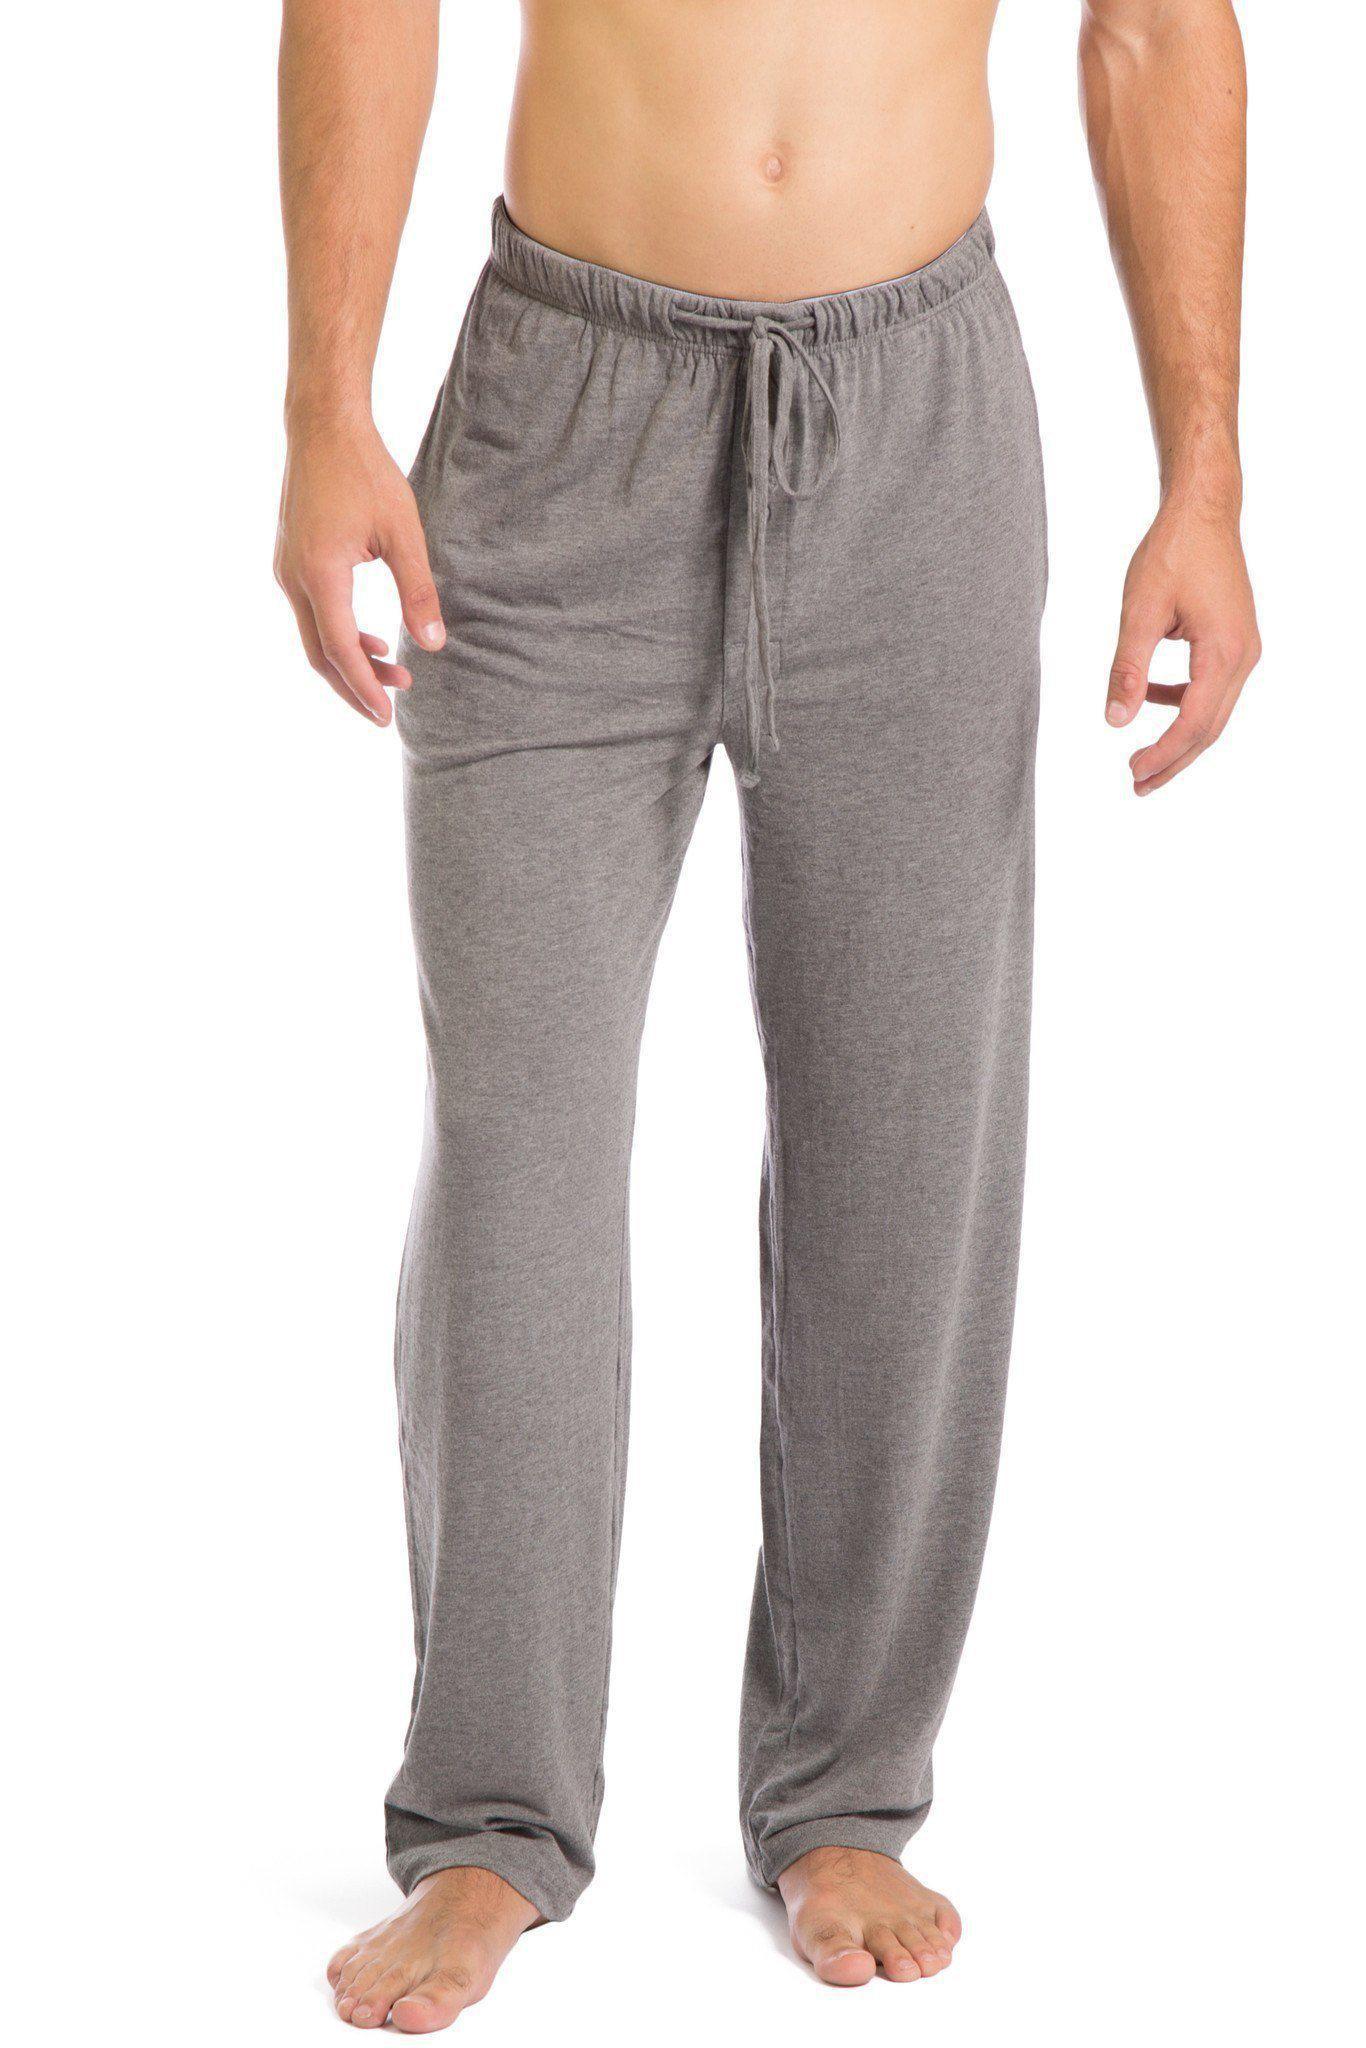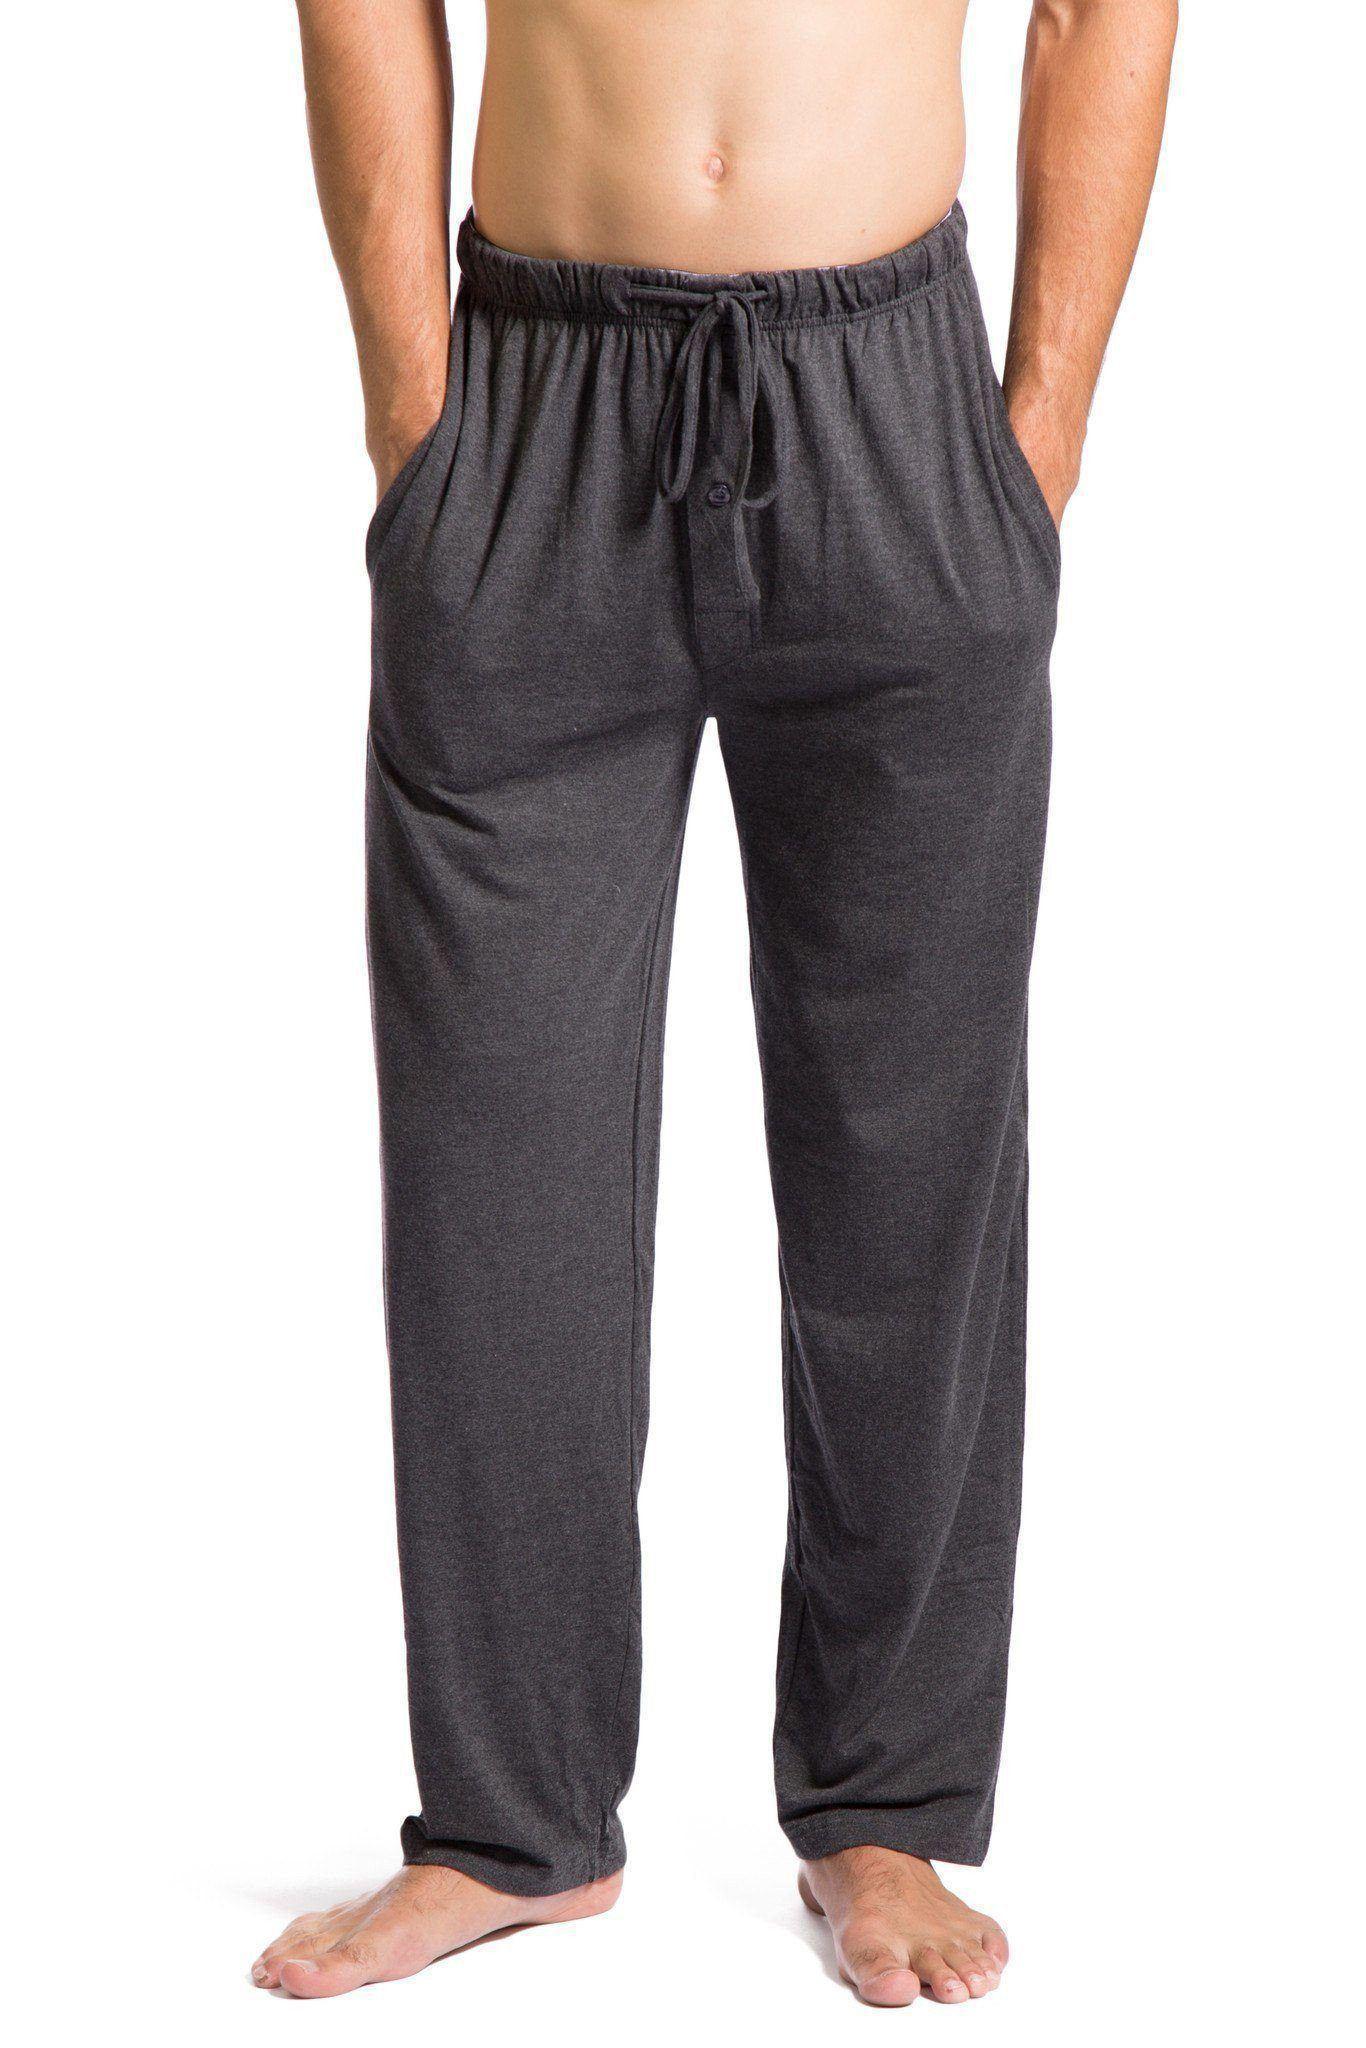The first image is the image on the left, the second image is the image on the right. Assess this claim about the two images: "All men's pajama pants have an elastic waist and a drawstring at the center front.". Correct or not? Answer yes or no. Yes. 